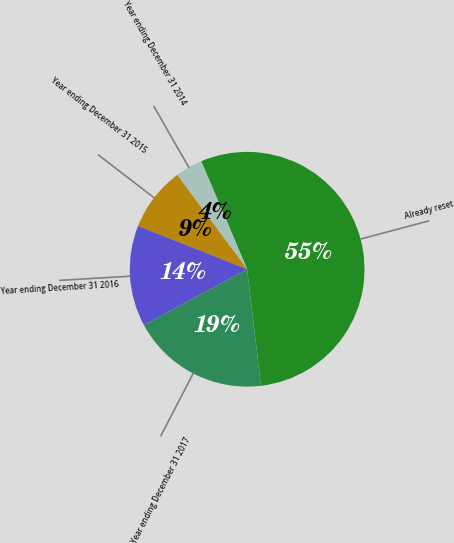<chart> <loc_0><loc_0><loc_500><loc_500><pie_chart><fcel>Already reset<fcel>Year ending December 31 2014<fcel>Year ending December 31 2015<fcel>Year ending December 31 2016<fcel>Year ending December 31 2017<nl><fcel>54.51%<fcel>3.76%<fcel>8.83%<fcel>13.91%<fcel>18.98%<nl></chart> 